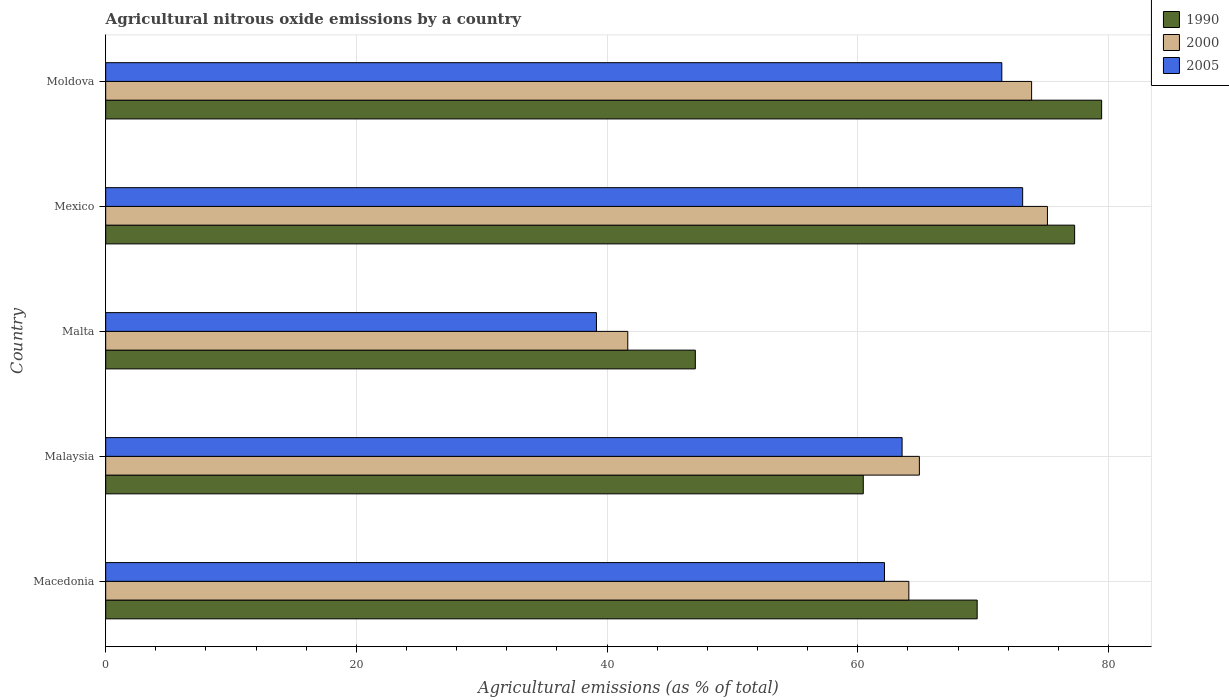Are the number of bars on each tick of the Y-axis equal?
Offer a terse response. Yes. How many bars are there on the 1st tick from the top?
Make the answer very short. 3. What is the label of the 4th group of bars from the top?
Give a very brief answer. Malaysia. What is the amount of agricultural nitrous oxide emitted in 2005 in Mexico?
Ensure brevity in your answer.  73.16. Across all countries, what is the maximum amount of agricultural nitrous oxide emitted in 2000?
Offer a very short reply. 75.14. Across all countries, what is the minimum amount of agricultural nitrous oxide emitted in 1990?
Provide a short and direct response. 47.04. In which country was the amount of agricultural nitrous oxide emitted in 1990 maximum?
Your answer should be compact. Moldova. In which country was the amount of agricultural nitrous oxide emitted in 1990 minimum?
Your response must be concise. Malta. What is the total amount of agricultural nitrous oxide emitted in 2000 in the graph?
Offer a very short reply. 319.66. What is the difference between the amount of agricultural nitrous oxide emitted in 2005 in Malta and that in Moldova?
Your answer should be compact. -32.34. What is the difference between the amount of agricultural nitrous oxide emitted in 2000 in Moldova and the amount of agricultural nitrous oxide emitted in 1990 in Malaysia?
Keep it short and to the point. 13.43. What is the average amount of agricultural nitrous oxide emitted in 2005 per country?
Give a very brief answer. 61.9. What is the difference between the amount of agricultural nitrous oxide emitted in 1990 and amount of agricultural nitrous oxide emitted in 2000 in Malaysia?
Provide a succinct answer. -4.47. In how many countries, is the amount of agricultural nitrous oxide emitted in 2000 greater than 48 %?
Ensure brevity in your answer.  4. What is the ratio of the amount of agricultural nitrous oxide emitted in 2005 in Macedonia to that in Mexico?
Offer a terse response. 0.85. Is the amount of agricultural nitrous oxide emitted in 1990 in Macedonia less than that in Malta?
Offer a terse response. No. What is the difference between the highest and the second highest amount of agricultural nitrous oxide emitted in 2000?
Make the answer very short. 1.26. What is the difference between the highest and the lowest amount of agricultural nitrous oxide emitted in 2005?
Ensure brevity in your answer.  34. What does the 3rd bar from the top in Macedonia represents?
Offer a very short reply. 1990. What does the 1st bar from the bottom in Mexico represents?
Your response must be concise. 1990. What is the difference between two consecutive major ticks on the X-axis?
Your response must be concise. 20. Are the values on the major ticks of X-axis written in scientific E-notation?
Provide a succinct answer. No. Does the graph contain any zero values?
Ensure brevity in your answer.  No. Does the graph contain grids?
Offer a very short reply. Yes. How many legend labels are there?
Offer a very short reply. 3. What is the title of the graph?
Make the answer very short. Agricultural nitrous oxide emissions by a country. Does "1966" appear as one of the legend labels in the graph?
Offer a terse response. No. What is the label or title of the X-axis?
Make the answer very short. Agricultural emissions (as % of total). What is the label or title of the Y-axis?
Keep it short and to the point. Country. What is the Agricultural emissions (as % of total) in 1990 in Macedonia?
Offer a terse response. 69.53. What is the Agricultural emissions (as % of total) in 2000 in Macedonia?
Offer a terse response. 64.08. What is the Agricultural emissions (as % of total) of 2005 in Macedonia?
Your answer should be compact. 62.13. What is the Agricultural emissions (as % of total) in 1990 in Malaysia?
Offer a terse response. 60.44. What is the Agricultural emissions (as % of total) in 2000 in Malaysia?
Offer a very short reply. 64.92. What is the Agricultural emissions (as % of total) of 2005 in Malaysia?
Your answer should be very brief. 63.54. What is the Agricultural emissions (as % of total) of 1990 in Malta?
Offer a very short reply. 47.04. What is the Agricultural emissions (as % of total) in 2000 in Malta?
Give a very brief answer. 41.65. What is the Agricultural emissions (as % of total) in 2005 in Malta?
Offer a terse response. 39.15. What is the Agricultural emissions (as % of total) in 1990 in Mexico?
Offer a very short reply. 77.3. What is the Agricultural emissions (as % of total) of 2000 in Mexico?
Your answer should be very brief. 75.14. What is the Agricultural emissions (as % of total) in 2005 in Mexico?
Ensure brevity in your answer.  73.16. What is the Agricultural emissions (as % of total) in 1990 in Moldova?
Your response must be concise. 79.46. What is the Agricultural emissions (as % of total) of 2000 in Moldova?
Offer a very short reply. 73.87. What is the Agricultural emissions (as % of total) of 2005 in Moldova?
Make the answer very short. 71.5. Across all countries, what is the maximum Agricultural emissions (as % of total) of 1990?
Your response must be concise. 79.46. Across all countries, what is the maximum Agricultural emissions (as % of total) in 2000?
Your answer should be very brief. 75.14. Across all countries, what is the maximum Agricultural emissions (as % of total) in 2005?
Your response must be concise. 73.16. Across all countries, what is the minimum Agricultural emissions (as % of total) of 1990?
Your answer should be very brief. 47.04. Across all countries, what is the minimum Agricultural emissions (as % of total) in 2000?
Your answer should be very brief. 41.65. Across all countries, what is the minimum Agricultural emissions (as % of total) of 2005?
Your answer should be compact. 39.15. What is the total Agricultural emissions (as % of total) of 1990 in the graph?
Offer a terse response. 333.78. What is the total Agricultural emissions (as % of total) of 2000 in the graph?
Provide a succinct answer. 319.66. What is the total Agricultural emissions (as % of total) of 2005 in the graph?
Provide a succinct answer. 309.48. What is the difference between the Agricultural emissions (as % of total) of 1990 in Macedonia and that in Malaysia?
Make the answer very short. 9.09. What is the difference between the Agricultural emissions (as % of total) of 2000 in Macedonia and that in Malaysia?
Offer a very short reply. -0.84. What is the difference between the Agricultural emissions (as % of total) of 2005 in Macedonia and that in Malaysia?
Keep it short and to the point. -1.41. What is the difference between the Agricultural emissions (as % of total) of 1990 in Macedonia and that in Malta?
Your answer should be compact. 22.49. What is the difference between the Agricultural emissions (as % of total) in 2000 in Macedonia and that in Malta?
Your response must be concise. 22.42. What is the difference between the Agricultural emissions (as % of total) of 2005 in Macedonia and that in Malta?
Offer a terse response. 22.98. What is the difference between the Agricultural emissions (as % of total) in 1990 in Macedonia and that in Mexico?
Make the answer very short. -7.78. What is the difference between the Agricultural emissions (as % of total) in 2000 in Macedonia and that in Mexico?
Keep it short and to the point. -11.06. What is the difference between the Agricultural emissions (as % of total) in 2005 in Macedonia and that in Mexico?
Provide a short and direct response. -11.03. What is the difference between the Agricultural emissions (as % of total) in 1990 in Macedonia and that in Moldova?
Your response must be concise. -9.93. What is the difference between the Agricultural emissions (as % of total) in 2000 in Macedonia and that in Moldova?
Make the answer very short. -9.79. What is the difference between the Agricultural emissions (as % of total) of 2005 in Macedonia and that in Moldova?
Provide a short and direct response. -9.36. What is the difference between the Agricultural emissions (as % of total) in 1990 in Malaysia and that in Malta?
Your answer should be very brief. 13.4. What is the difference between the Agricultural emissions (as % of total) in 2000 in Malaysia and that in Malta?
Give a very brief answer. 23.26. What is the difference between the Agricultural emissions (as % of total) in 2005 in Malaysia and that in Malta?
Your answer should be compact. 24.39. What is the difference between the Agricultural emissions (as % of total) of 1990 in Malaysia and that in Mexico?
Make the answer very short. -16.86. What is the difference between the Agricultural emissions (as % of total) in 2000 in Malaysia and that in Mexico?
Your response must be concise. -10.22. What is the difference between the Agricultural emissions (as % of total) in 2005 in Malaysia and that in Mexico?
Your answer should be compact. -9.62. What is the difference between the Agricultural emissions (as % of total) of 1990 in Malaysia and that in Moldova?
Offer a terse response. -19.02. What is the difference between the Agricultural emissions (as % of total) in 2000 in Malaysia and that in Moldova?
Your answer should be very brief. -8.95. What is the difference between the Agricultural emissions (as % of total) of 2005 in Malaysia and that in Moldova?
Ensure brevity in your answer.  -7.96. What is the difference between the Agricultural emissions (as % of total) of 1990 in Malta and that in Mexico?
Ensure brevity in your answer.  -30.26. What is the difference between the Agricultural emissions (as % of total) of 2000 in Malta and that in Mexico?
Make the answer very short. -33.48. What is the difference between the Agricultural emissions (as % of total) of 2005 in Malta and that in Mexico?
Offer a very short reply. -34. What is the difference between the Agricultural emissions (as % of total) in 1990 in Malta and that in Moldova?
Ensure brevity in your answer.  -32.42. What is the difference between the Agricultural emissions (as % of total) of 2000 in Malta and that in Moldova?
Your answer should be very brief. -32.22. What is the difference between the Agricultural emissions (as % of total) in 2005 in Malta and that in Moldova?
Make the answer very short. -32.34. What is the difference between the Agricultural emissions (as % of total) in 1990 in Mexico and that in Moldova?
Offer a terse response. -2.15. What is the difference between the Agricultural emissions (as % of total) of 2000 in Mexico and that in Moldova?
Offer a very short reply. 1.26. What is the difference between the Agricultural emissions (as % of total) of 2005 in Mexico and that in Moldova?
Make the answer very short. 1.66. What is the difference between the Agricultural emissions (as % of total) in 1990 in Macedonia and the Agricultural emissions (as % of total) in 2000 in Malaysia?
Offer a terse response. 4.61. What is the difference between the Agricultural emissions (as % of total) of 1990 in Macedonia and the Agricultural emissions (as % of total) of 2005 in Malaysia?
Your answer should be compact. 5.99. What is the difference between the Agricultural emissions (as % of total) in 2000 in Macedonia and the Agricultural emissions (as % of total) in 2005 in Malaysia?
Make the answer very short. 0.54. What is the difference between the Agricultural emissions (as % of total) in 1990 in Macedonia and the Agricultural emissions (as % of total) in 2000 in Malta?
Your answer should be very brief. 27.88. What is the difference between the Agricultural emissions (as % of total) in 1990 in Macedonia and the Agricultural emissions (as % of total) in 2005 in Malta?
Give a very brief answer. 30.38. What is the difference between the Agricultural emissions (as % of total) of 2000 in Macedonia and the Agricultural emissions (as % of total) of 2005 in Malta?
Offer a terse response. 24.92. What is the difference between the Agricultural emissions (as % of total) of 1990 in Macedonia and the Agricultural emissions (as % of total) of 2000 in Mexico?
Give a very brief answer. -5.61. What is the difference between the Agricultural emissions (as % of total) of 1990 in Macedonia and the Agricultural emissions (as % of total) of 2005 in Mexico?
Your answer should be very brief. -3.63. What is the difference between the Agricultural emissions (as % of total) of 2000 in Macedonia and the Agricultural emissions (as % of total) of 2005 in Mexico?
Offer a terse response. -9.08. What is the difference between the Agricultural emissions (as % of total) of 1990 in Macedonia and the Agricultural emissions (as % of total) of 2000 in Moldova?
Provide a short and direct response. -4.34. What is the difference between the Agricultural emissions (as % of total) in 1990 in Macedonia and the Agricultural emissions (as % of total) in 2005 in Moldova?
Make the answer very short. -1.97. What is the difference between the Agricultural emissions (as % of total) in 2000 in Macedonia and the Agricultural emissions (as % of total) in 2005 in Moldova?
Give a very brief answer. -7.42. What is the difference between the Agricultural emissions (as % of total) in 1990 in Malaysia and the Agricultural emissions (as % of total) in 2000 in Malta?
Provide a succinct answer. 18.79. What is the difference between the Agricultural emissions (as % of total) in 1990 in Malaysia and the Agricultural emissions (as % of total) in 2005 in Malta?
Keep it short and to the point. 21.29. What is the difference between the Agricultural emissions (as % of total) of 2000 in Malaysia and the Agricultural emissions (as % of total) of 2005 in Malta?
Provide a succinct answer. 25.76. What is the difference between the Agricultural emissions (as % of total) in 1990 in Malaysia and the Agricultural emissions (as % of total) in 2000 in Mexico?
Ensure brevity in your answer.  -14.69. What is the difference between the Agricultural emissions (as % of total) in 1990 in Malaysia and the Agricultural emissions (as % of total) in 2005 in Mexico?
Ensure brevity in your answer.  -12.72. What is the difference between the Agricultural emissions (as % of total) in 2000 in Malaysia and the Agricultural emissions (as % of total) in 2005 in Mexico?
Make the answer very short. -8.24. What is the difference between the Agricultural emissions (as % of total) in 1990 in Malaysia and the Agricultural emissions (as % of total) in 2000 in Moldova?
Provide a succinct answer. -13.43. What is the difference between the Agricultural emissions (as % of total) in 1990 in Malaysia and the Agricultural emissions (as % of total) in 2005 in Moldova?
Provide a succinct answer. -11.05. What is the difference between the Agricultural emissions (as % of total) of 2000 in Malaysia and the Agricultural emissions (as % of total) of 2005 in Moldova?
Provide a short and direct response. -6.58. What is the difference between the Agricultural emissions (as % of total) of 1990 in Malta and the Agricultural emissions (as % of total) of 2000 in Mexico?
Offer a very short reply. -28.09. What is the difference between the Agricultural emissions (as % of total) of 1990 in Malta and the Agricultural emissions (as % of total) of 2005 in Mexico?
Provide a succinct answer. -26.12. What is the difference between the Agricultural emissions (as % of total) in 2000 in Malta and the Agricultural emissions (as % of total) in 2005 in Mexico?
Provide a short and direct response. -31.5. What is the difference between the Agricultural emissions (as % of total) of 1990 in Malta and the Agricultural emissions (as % of total) of 2000 in Moldova?
Give a very brief answer. -26.83. What is the difference between the Agricultural emissions (as % of total) in 1990 in Malta and the Agricultural emissions (as % of total) in 2005 in Moldova?
Offer a terse response. -24.45. What is the difference between the Agricultural emissions (as % of total) of 2000 in Malta and the Agricultural emissions (as % of total) of 2005 in Moldova?
Provide a short and direct response. -29.84. What is the difference between the Agricultural emissions (as % of total) of 1990 in Mexico and the Agricultural emissions (as % of total) of 2000 in Moldova?
Your answer should be very brief. 3.43. What is the difference between the Agricultural emissions (as % of total) in 1990 in Mexico and the Agricultural emissions (as % of total) in 2005 in Moldova?
Your response must be concise. 5.81. What is the difference between the Agricultural emissions (as % of total) in 2000 in Mexico and the Agricultural emissions (as % of total) in 2005 in Moldova?
Your response must be concise. 3.64. What is the average Agricultural emissions (as % of total) of 1990 per country?
Your answer should be very brief. 66.76. What is the average Agricultural emissions (as % of total) in 2000 per country?
Your answer should be compact. 63.93. What is the average Agricultural emissions (as % of total) in 2005 per country?
Provide a succinct answer. 61.9. What is the difference between the Agricultural emissions (as % of total) of 1990 and Agricultural emissions (as % of total) of 2000 in Macedonia?
Your answer should be compact. 5.45. What is the difference between the Agricultural emissions (as % of total) of 1990 and Agricultural emissions (as % of total) of 2005 in Macedonia?
Offer a very short reply. 7.4. What is the difference between the Agricultural emissions (as % of total) in 2000 and Agricultural emissions (as % of total) in 2005 in Macedonia?
Give a very brief answer. 1.95. What is the difference between the Agricultural emissions (as % of total) of 1990 and Agricultural emissions (as % of total) of 2000 in Malaysia?
Keep it short and to the point. -4.47. What is the difference between the Agricultural emissions (as % of total) in 1990 and Agricultural emissions (as % of total) in 2005 in Malaysia?
Keep it short and to the point. -3.1. What is the difference between the Agricultural emissions (as % of total) of 2000 and Agricultural emissions (as % of total) of 2005 in Malaysia?
Your answer should be compact. 1.38. What is the difference between the Agricultural emissions (as % of total) of 1990 and Agricultural emissions (as % of total) of 2000 in Malta?
Keep it short and to the point. 5.39. What is the difference between the Agricultural emissions (as % of total) of 1990 and Agricultural emissions (as % of total) of 2005 in Malta?
Ensure brevity in your answer.  7.89. What is the difference between the Agricultural emissions (as % of total) in 2000 and Agricultural emissions (as % of total) in 2005 in Malta?
Keep it short and to the point. 2.5. What is the difference between the Agricultural emissions (as % of total) in 1990 and Agricultural emissions (as % of total) in 2000 in Mexico?
Provide a succinct answer. 2.17. What is the difference between the Agricultural emissions (as % of total) of 1990 and Agricultural emissions (as % of total) of 2005 in Mexico?
Provide a succinct answer. 4.15. What is the difference between the Agricultural emissions (as % of total) in 2000 and Agricultural emissions (as % of total) in 2005 in Mexico?
Your answer should be compact. 1.98. What is the difference between the Agricultural emissions (as % of total) in 1990 and Agricultural emissions (as % of total) in 2000 in Moldova?
Give a very brief answer. 5.59. What is the difference between the Agricultural emissions (as % of total) of 1990 and Agricultural emissions (as % of total) of 2005 in Moldova?
Offer a terse response. 7.96. What is the difference between the Agricultural emissions (as % of total) of 2000 and Agricultural emissions (as % of total) of 2005 in Moldova?
Provide a succinct answer. 2.38. What is the ratio of the Agricultural emissions (as % of total) of 1990 in Macedonia to that in Malaysia?
Offer a very short reply. 1.15. What is the ratio of the Agricultural emissions (as % of total) in 2000 in Macedonia to that in Malaysia?
Provide a succinct answer. 0.99. What is the ratio of the Agricultural emissions (as % of total) of 2005 in Macedonia to that in Malaysia?
Your answer should be compact. 0.98. What is the ratio of the Agricultural emissions (as % of total) in 1990 in Macedonia to that in Malta?
Your answer should be very brief. 1.48. What is the ratio of the Agricultural emissions (as % of total) in 2000 in Macedonia to that in Malta?
Ensure brevity in your answer.  1.54. What is the ratio of the Agricultural emissions (as % of total) in 2005 in Macedonia to that in Malta?
Provide a short and direct response. 1.59. What is the ratio of the Agricultural emissions (as % of total) in 1990 in Macedonia to that in Mexico?
Give a very brief answer. 0.9. What is the ratio of the Agricultural emissions (as % of total) of 2000 in Macedonia to that in Mexico?
Your answer should be very brief. 0.85. What is the ratio of the Agricultural emissions (as % of total) of 2005 in Macedonia to that in Mexico?
Provide a short and direct response. 0.85. What is the ratio of the Agricultural emissions (as % of total) of 1990 in Macedonia to that in Moldova?
Your response must be concise. 0.88. What is the ratio of the Agricultural emissions (as % of total) of 2000 in Macedonia to that in Moldova?
Make the answer very short. 0.87. What is the ratio of the Agricultural emissions (as % of total) in 2005 in Macedonia to that in Moldova?
Your response must be concise. 0.87. What is the ratio of the Agricultural emissions (as % of total) of 1990 in Malaysia to that in Malta?
Ensure brevity in your answer.  1.28. What is the ratio of the Agricultural emissions (as % of total) of 2000 in Malaysia to that in Malta?
Your response must be concise. 1.56. What is the ratio of the Agricultural emissions (as % of total) in 2005 in Malaysia to that in Malta?
Make the answer very short. 1.62. What is the ratio of the Agricultural emissions (as % of total) of 1990 in Malaysia to that in Mexico?
Keep it short and to the point. 0.78. What is the ratio of the Agricultural emissions (as % of total) in 2000 in Malaysia to that in Mexico?
Give a very brief answer. 0.86. What is the ratio of the Agricultural emissions (as % of total) in 2005 in Malaysia to that in Mexico?
Your answer should be very brief. 0.87. What is the ratio of the Agricultural emissions (as % of total) in 1990 in Malaysia to that in Moldova?
Your answer should be very brief. 0.76. What is the ratio of the Agricultural emissions (as % of total) in 2000 in Malaysia to that in Moldova?
Offer a very short reply. 0.88. What is the ratio of the Agricultural emissions (as % of total) in 2005 in Malaysia to that in Moldova?
Make the answer very short. 0.89. What is the ratio of the Agricultural emissions (as % of total) in 1990 in Malta to that in Mexico?
Ensure brevity in your answer.  0.61. What is the ratio of the Agricultural emissions (as % of total) in 2000 in Malta to that in Mexico?
Make the answer very short. 0.55. What is the ratio of the Agricultural emissions (as % of total) in 2005 in Malta to that in Mexico?
Provide a succinct answer. 0.54. What is the ratio of the Agricultural emissions (as % of total) in 1990 in Malta to that in Moldova?
Your answer should be very brief. 0.59. What is the ratio of the Agricultural emissions (as % of total) in 2000 in Malta to that in Moldova?
Provide a succinct answer. 0.56. What is the ratio of the Agricultural emissions (as % of total) of 2005 in Malta to that in Moldova?
Provide a succinct answer. 0.55. What is the ratio of the Agricultural emissions (as % of total) in 1990 in Mexico to that in Moldova?
Offer a terse response. 0.97. What is the ratio of the Agricultural emissions (as % of total) of 2000 in Mexico to that in Moldova?
Offer a terse response. 1.02. What is the ratio of the Agricultural emissions (as % of total) of 2005 in Mexico to that in Moldova?
Give a very brief answer. 1.02. What is the difference between the highest and the second highest Agricultural emissions (as % of total) in 1990?
Keep it short and to the point. 2.15. What is the difference between the highest and the second highest Agricultural emissions (as % of total) of 2000?
Make the answer very short. 1.26. What is the difference between the highest and the second highest Agricultural emissions (as % of total) in 2005?
Offer a terse response. 1.66. What is the difference between the highest and the lowest Agricultural emissions (as % of total) of 1990?
Keep it short and to the point. 32.42. What is the difference between the highest and the lowest Agricultural emissions (as % of total) of 2000?
Your answer should be very brief. 33.48. What is the difference between the highest and the lowest Agricultural emissions (as % of total) of 2005?
Make the answer very short. 34. 